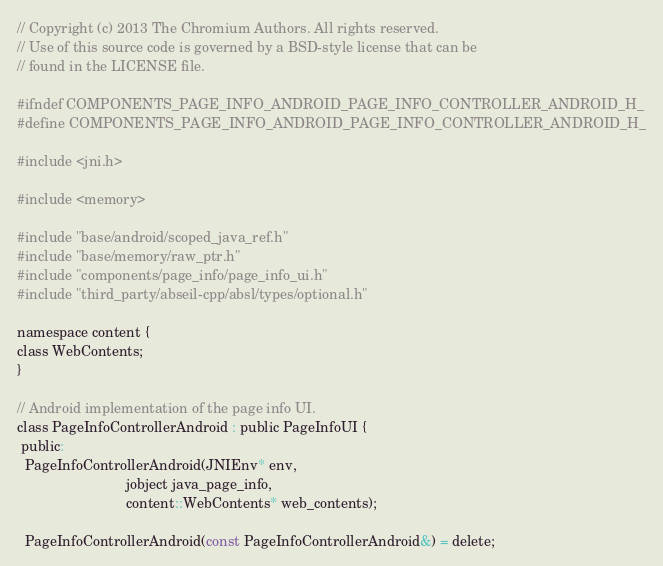Convert code to text. <code><loc_0><loc_0><loc_500><loc_500><_C_>// Copyright (c) 2013 The Chromium Authors. All rights reserved.
// Use of this source code is governed by a BSD-style license that can be
// found in the LICENSE file.

#ifndef COMPONENTS_PAGE_INFO_ANDROID_PAGE_INFO_CONTROLLER_ANDROID_H_
#define COMPONENTS_PAGE_INFO_ANDROID_PAGE_INFO_CONTROLLER_ANDROID_H_

#include <jni.h>

#include <memory>

#include "base/android/scoped_java_ref.h"
#include "base/memory/raw_ptr.h"
#include "components/page_info/page_info_ui.h"
#include "third_party/abseil-cpp/absl/types/optional.h"

namespace content {
class WebContents;
}

// Android implementation of the page info UI.
class PageInfoControllerAndroid : public PageInfoUI {
 public:
  PageInfoControllerAndroid(JNIEnv* env,
                            jobject java_page_info,
                            content::WebContents* web_contents);

  PageInfoControllerAndroid(const PageInfoControllerAndroid&) = delete;</code> 